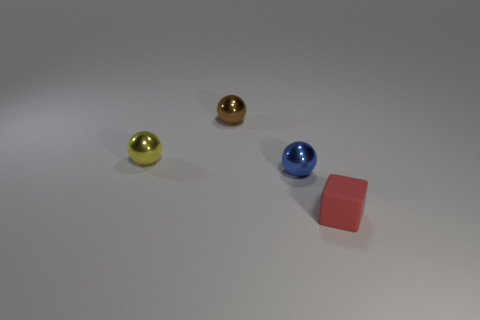Subtract all tiny yellow spheres. How many spheres are left? 2 Add 1 small red rubber objects. How many objects exist? 5 Subtract all yellow spheres. How many spheres are left? 2 Subtract all balls. How many objects are left? 1 Subtract all red rubber blocks. Subtract all tiny brown shiny balls. How many objects are left? 2 Add 2 brown metal objects. How many brown metal objects are left? 3 Add 1 cyan cylinders. How many cyan cylinders exist? 1 Subtract 0 red cylinders. How many objects are left? 4 Subtract 1 cubes. How many cubes are left? 0 Subtract all green spheres. Subtract all blue cylinders. How many spheres are left? 3 